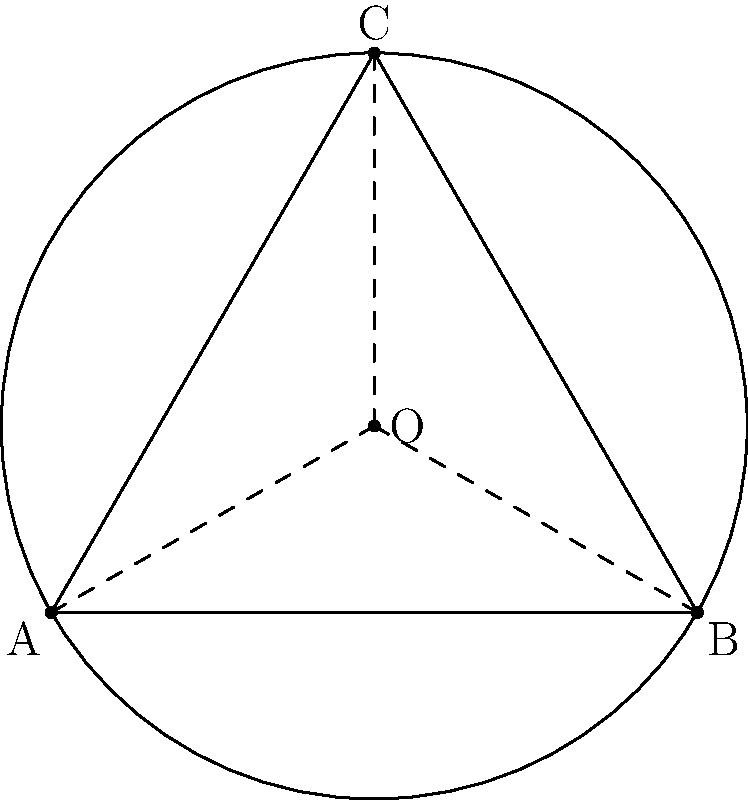In a city planning project, three police stations are to be placed at the vertices of an equilateral triangle ABC with side length 100 km. To ensure optimal coverage, a central dispatch center (O) needs to be located such that it is equidistant from all three stations. What is the radius (in km) of the circle that passes through all three police stations, representing the coverage area of the central dispatch? Let's approach this step-by-step:

1) In an equilateral triangle, the center of the circumscribed circle (O) is located at the intersection of the three angle bisectors.

2) The radius of this circle is given by the formula:
   $$R = \frac{a}{\sqrt{3}}$$
   where $a$ is the side length of the equilateral triangle.

3) Given that the side length is 100 km, we can substitute this into our formula:
   $$R = \frac{100}{\sqrt{3}}$$

4) Simplifying:
   $$R = \frac{100}{\sqrt{3}} \approx 57.74 \text{ km}$$

5) This radius represents the distance from the central dispatch to each police station, which is the optimal placement for equal coverage of all three stations.
Answer: $\frac{100}{\sqrt{3}}$ km (approximately 57.74 km) 